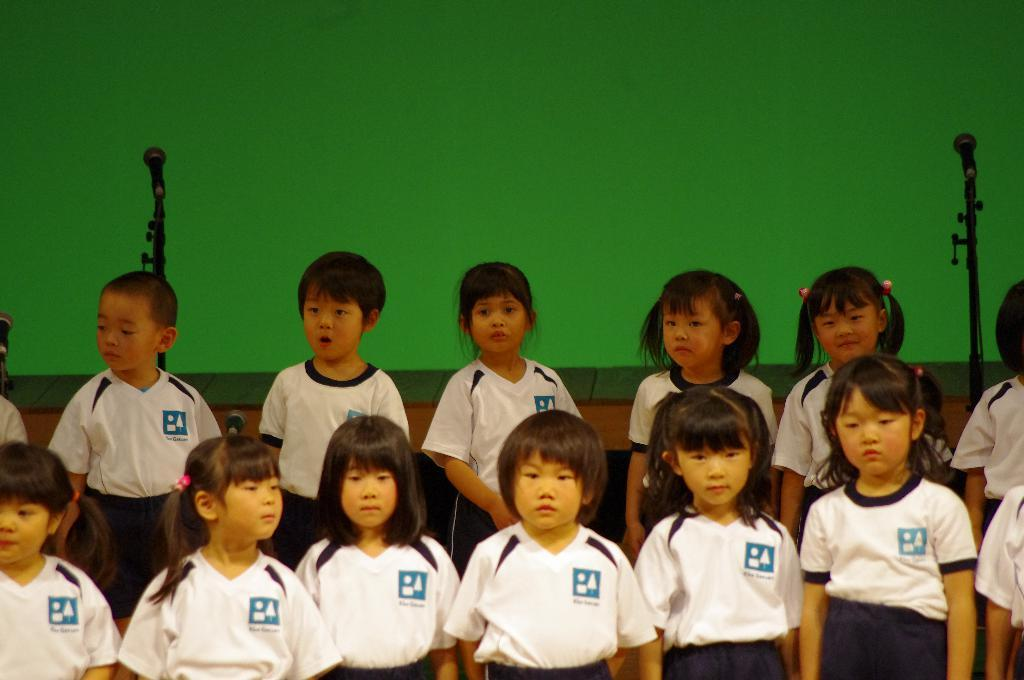Who is present in the image? There are children in the image. Where are the children located in the image? The children are in the front of the image. What are the children wearing? The children are wearing white-colored dresses. What can be seen in the background of the image? There are mics and a green-colored wall in the background of the image. What type of coast can be seen in the image? There is no coast present in the image; it features children in the front and a background with mics and a green-colored wall. 